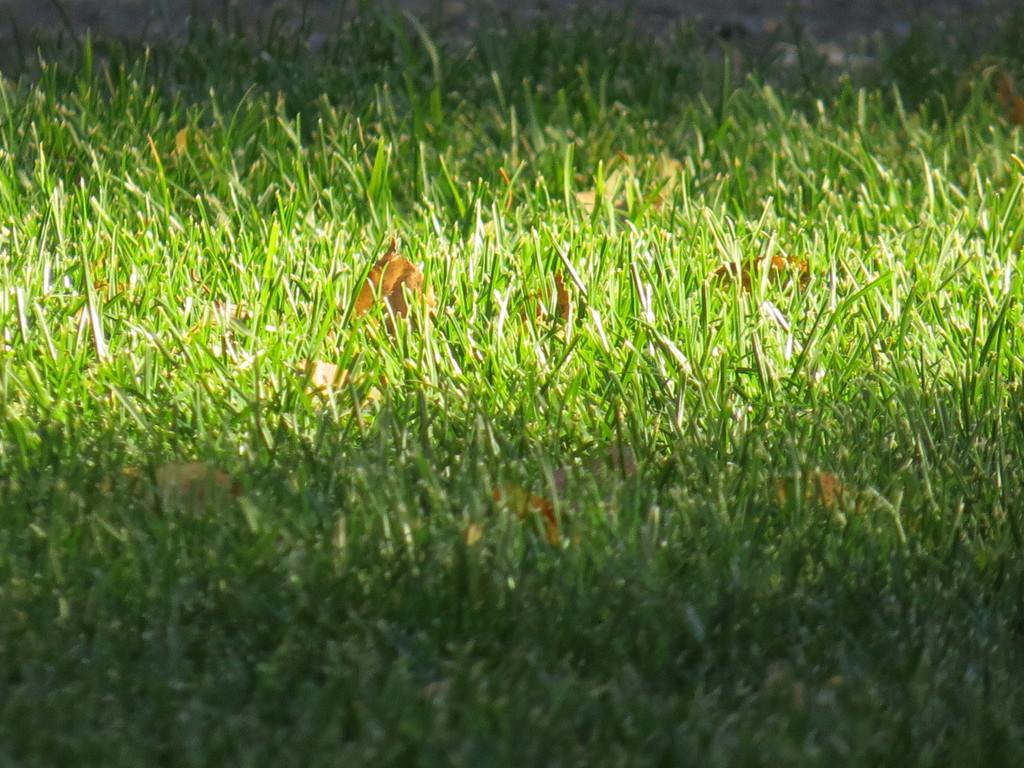What type of surface can be seen in the image? There is a grass path in the image. Are there any additional elements on the grass path? Yes, there are dry leaves on the grass path. What type of fowl can be seen walking on the grass path in the image? There are no fowl present in the image; it only features a grass path with dry leaves. 